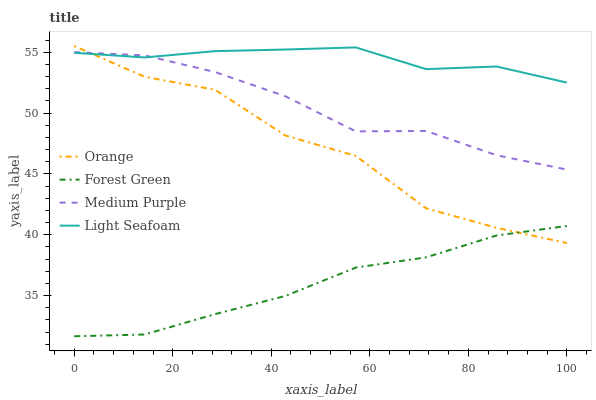Does Forest Green have the minimum area under the curve?
Answer yes or no. Yes. Does Light Seafoam have the maximum area under the curve?
Answer yes or no. Yes. Does Medium Purple have the minimum area under the curve?
Answer yes or no. No. Does Medium Purple have the maximum area under the curve?
Answer yes or no. No. Is Forest Green the smoothest?
Answer yes or no. Yes. Is Orange the roughest?
Answer yes or no. Yes. Is Medium Purple the smoothest?
Answer yes or no. No. Is Medium Purple the roughest?
Answer yes or no. No. Does Forest Green have the lowest value?
Answer yes or no. Yes. Does Medium Purple have the lowest value?
Answer yes or no. No. Does Orange have the highest value?
Answer yes or no. Yes. Does Medium Purple have the highest value?
Answer yes or no. No. Is Forest Green less than Light Seafoam?
Answer yes or no. Yes. Is Light Seafoam greater than Forest Green?
Answer yes or no. Yes. Does Medium Purple intersect Orange?
Answer yes or no. Yes. Is Medium Purple less than Orange?
Answer yes or no. No. Is Medium Purple greater than Orange?
Answer yes or no. No. Does Forest Green intersect Light Seafoam?
Answer yes or no. No. 